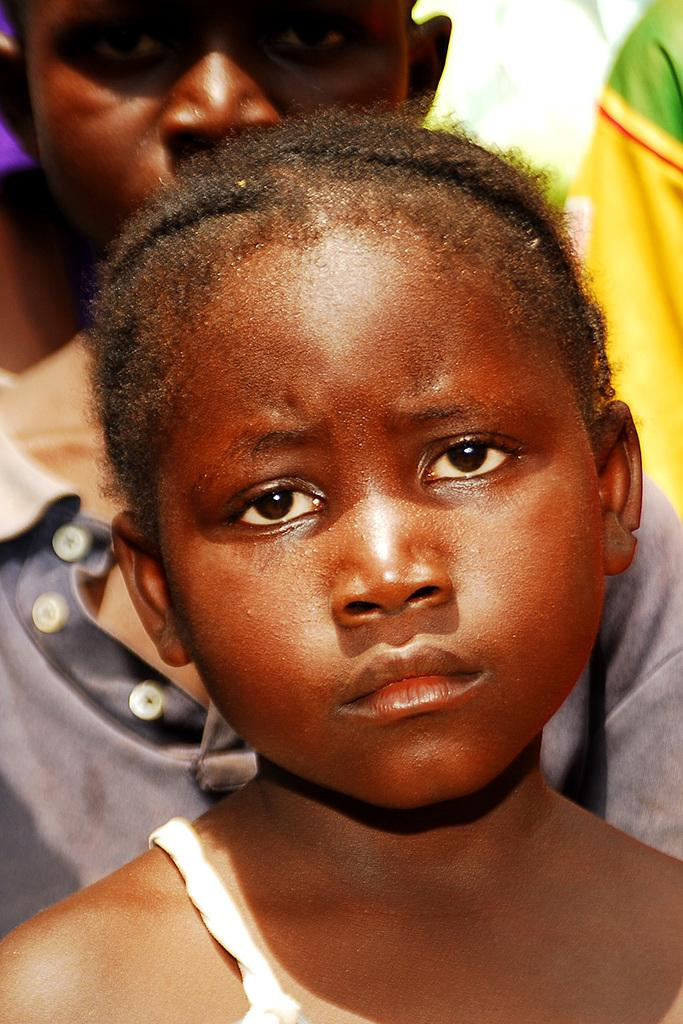How many children are present in the image? There are two children in the image. What year is depicted in the image? The provided facts do not mention any specific year, and there is no indication of a year in the image. 